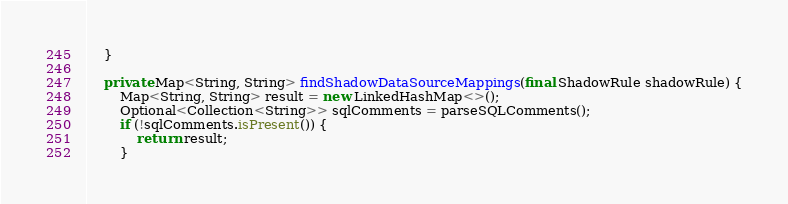Convert code to text. <code><loc_0><loc_0><loc_500><loc_500><_Java_>    }
    
    private Map<String, String> findShadowDataSourceMappings(final ShadowRule shadowRule) {
        Map<String, String> result = new LinkedHashMap<>();
        Optional<Collection<String>> sqlComments = parseSQLComments();
        if (!sqlComments.isPresent()) {
            return result;
        }</code> 